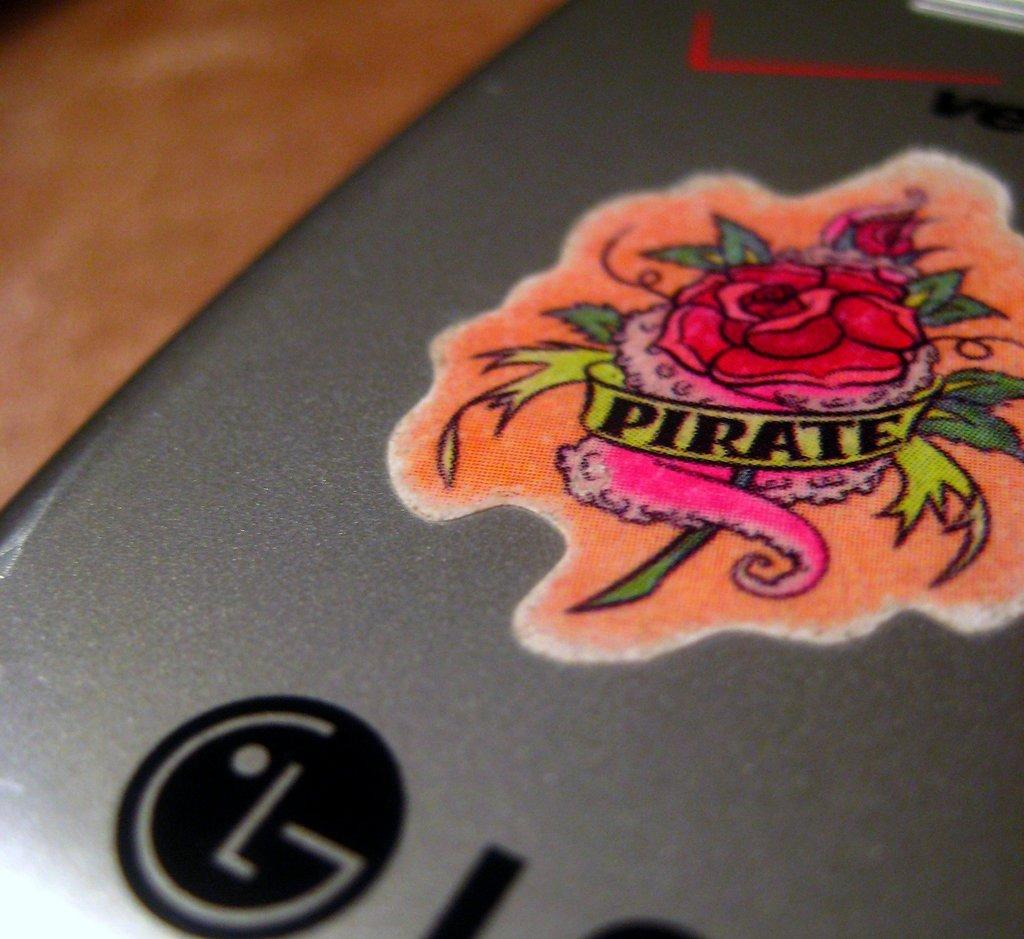What object is present in the image? There is a mobile in the image. What is on the mobile? The mobile has a sticker on it. Where is the mobile located? The mobile is placed on a desk. How many eyes can be seen on the mobile in the image? There are no eyes present on the mobile in the image. 